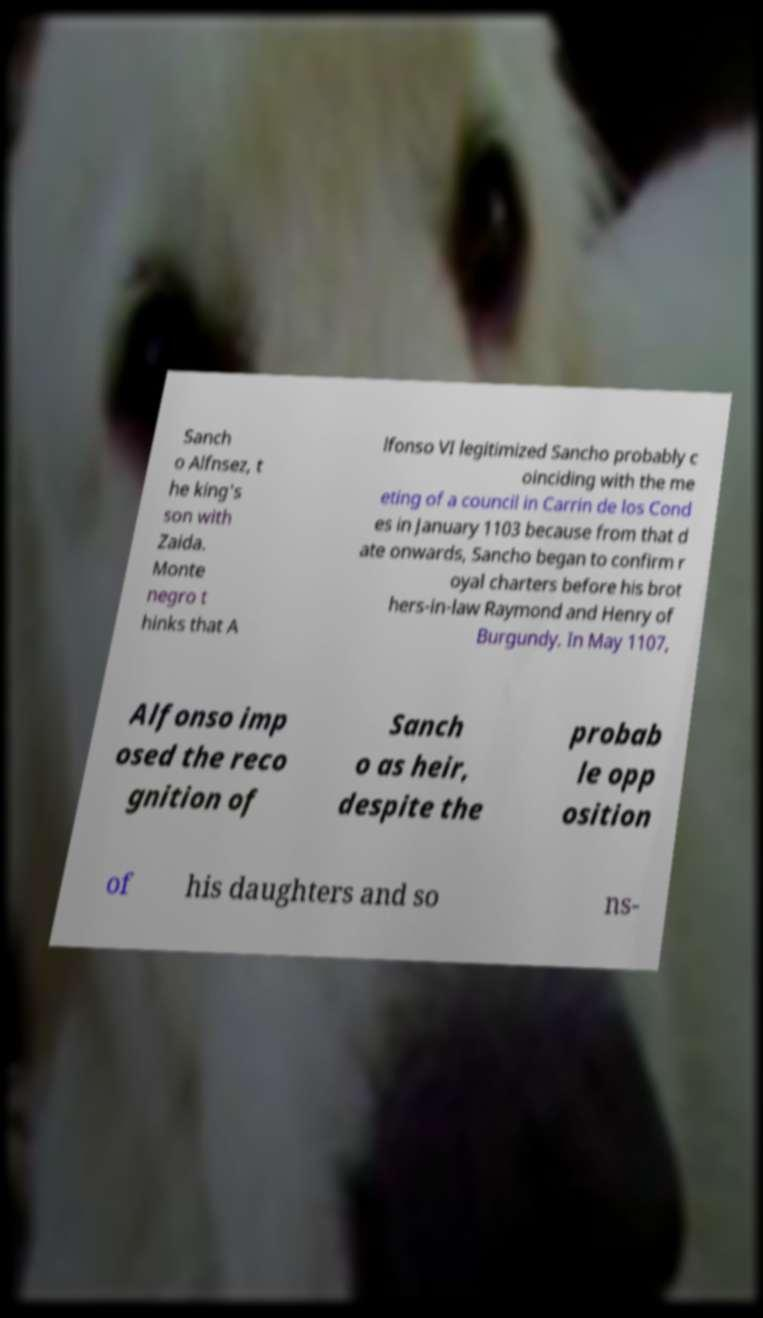There's text embedded in this image that I need extracted. Can you transcribe it verbatim? Sanch o Alfnsez, t he king's son with Zaida. Monte negro t hinks that A lfonso VI legitimized Sancho probably c oinciding with the me eting of a council in Carrin de los Cond es in January 1103 because from that d ate onwards, Sancho began to confirm r oyal charters before his brot hers-in-law Raymond and Henry of Burgundy. In May 1107, Alfonso imp osed the reco gnition of Sanch o as heir, despite the probab le opp osition of his daughters and so ns- 